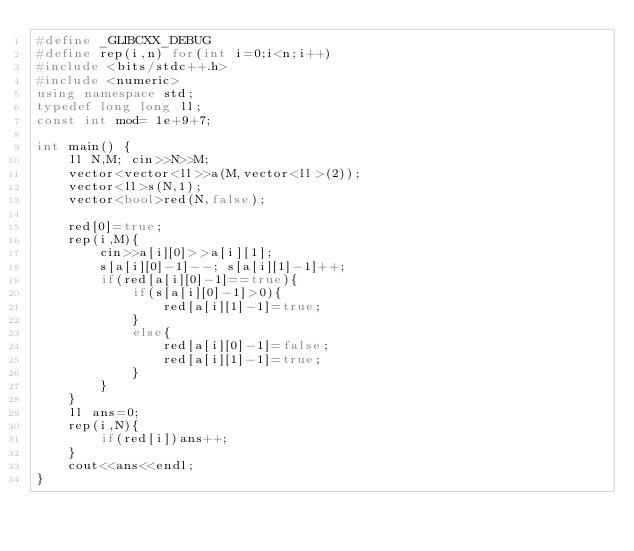<code> <loc_0><loc_0><loc_500><loc_500><_C++_>#define _GLIBCXX_DEBUG
#define rep(i,n) for(int i=0;i<n;i++)
#include <bits/stdc++.h>
#include <numeric>
using namespace std;
typedef long long ll;
const int mod= 1e+9+7;

int main() {
    ll N,M; cin>>N>>M;
    vector<vector<ll>>a(M,vector<ll>(2));
    vector<ll>s(N,1);
    vector<bool>red(N,false);

    red[0]=true;
    rep(i,M){
        cin>>a[i][0]>>a[i][1];
        s[a[i][0]-1]--; s[a[i][1]-1]++;
        if(red[a[i][0]-1]==true){
            if(s[a[i][0]-1]>0){
                red[a[i][1]-1]=true;
            }
            else{
                red[a[i][0]-1]=false;
                red[a[i][1]-1]=true;
            }
        }
    }
    ll ans=0;
    rep(i,N){
        if(red[i])ans++;
    }
    cout<<ans<<endl;
}</code> 